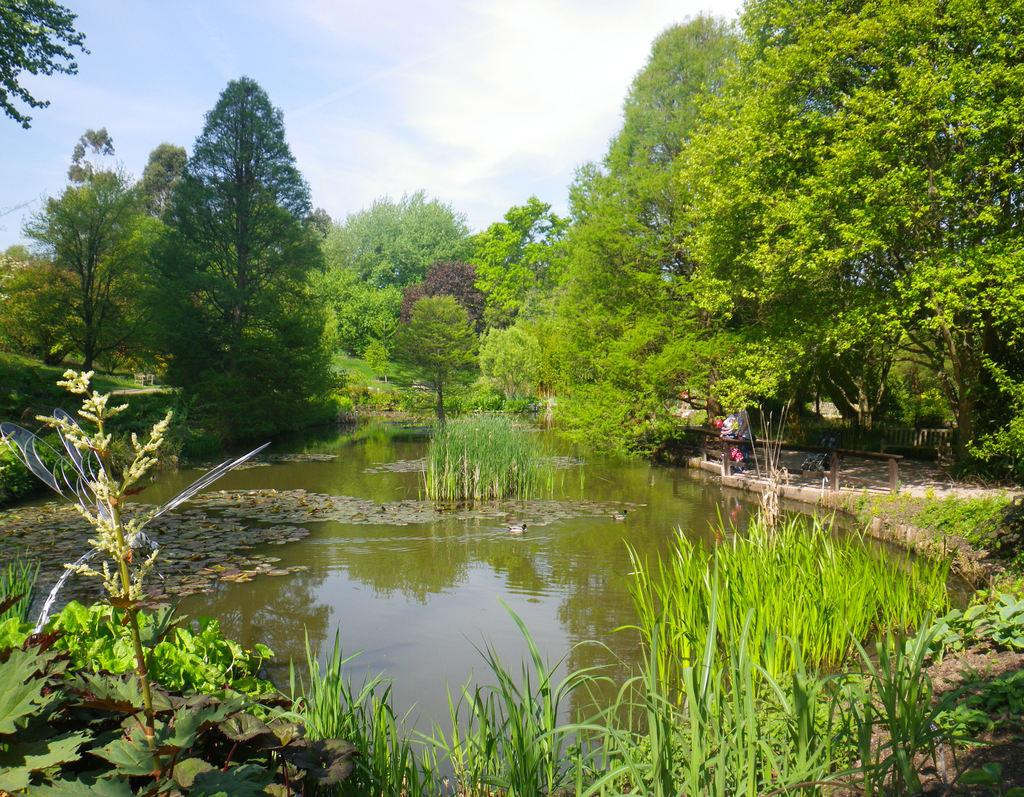What type of plants are in the image? There are plants in water in the image. What other natural elements can be seen in the image? There are trees visible in the image. What is visible in the background of the image? The sky is visible in the background of the image. What can be observed in the sky? Clouds are present in the sky. What type of feather can be seen floating in the water with the plants? There is no feather present in the image; it only features plants in water. How does the society depicted in the image interact with the marble sculptures? There is no society or marble sculptures present in the image. 